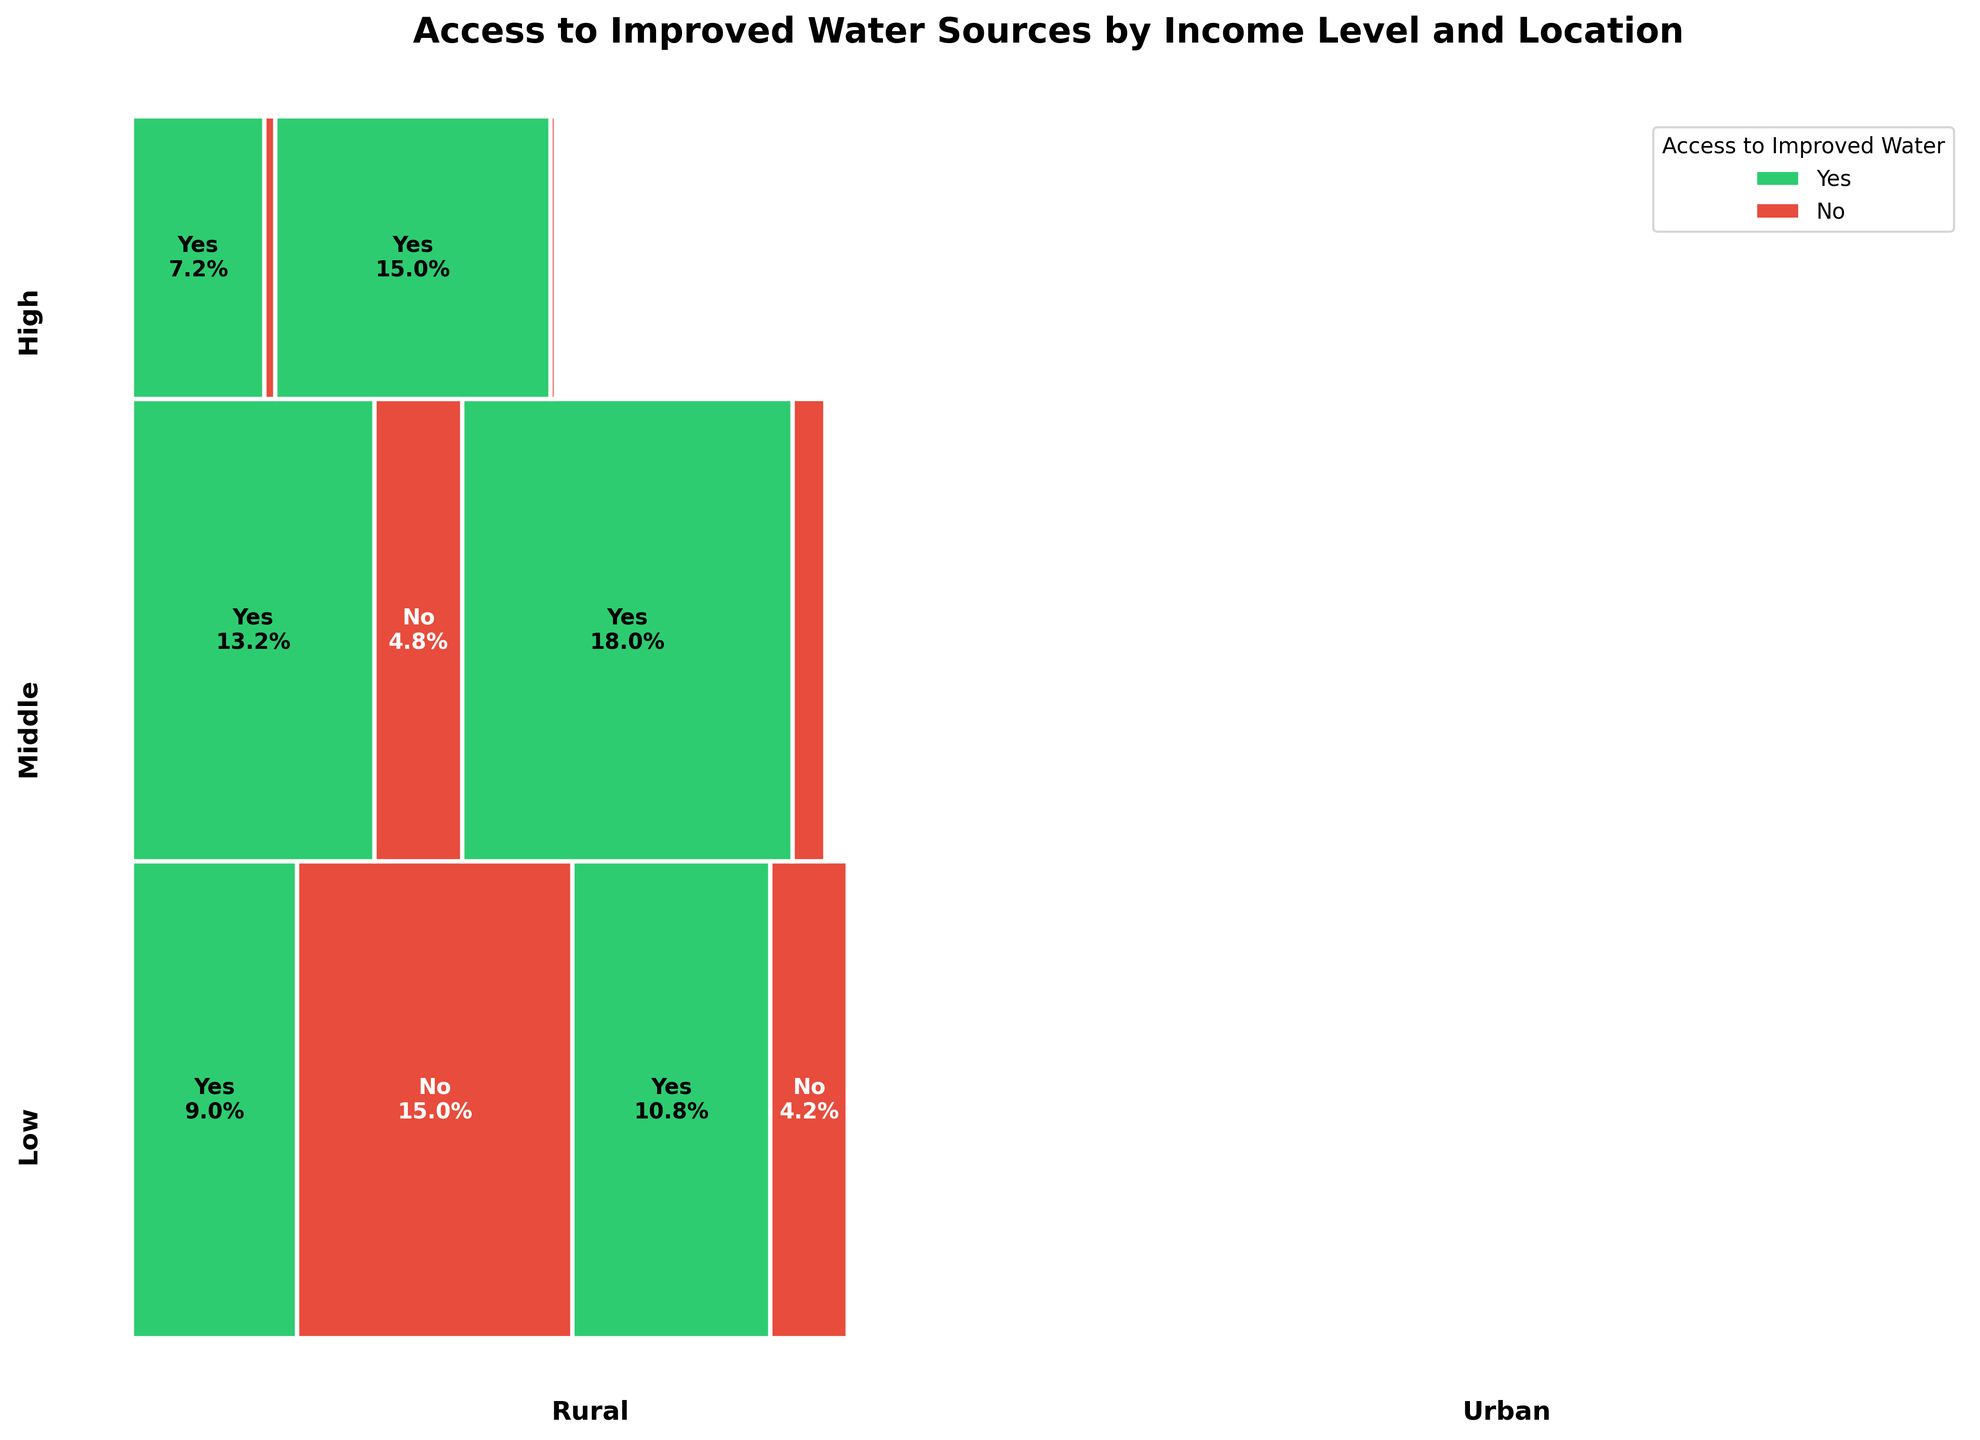What percentage of the urban population in low-income countries has access to improved water sources? In the mosaic plot, look at the segment labeled "Urban" under "Low" income level. The figure shows this segment explicitly marked with percentages for access to improved water sources.
Answer: 72% What is the total proportion of the population without access to improved water sources across all regions and income levels? Sum up the width of all red segments in the plot. Red segments represent the proportion of the population without access to improved water sources.
Answer: Approximately 30.6% Which geographical location has a higher percentage of people with access to improved water sources at the high-income level, rural or urban? Compare the widths of green segments (representing access) for rural and urban within the high-income level section.
Answer: Urban How does the proportion of the rural population with no access to improved water sources compare between low and middle-income levels? Look at the red segments for "Rural" under both low and middle-income levels. Compare their widths.
Answer: The proportion is higher in low-income levels Which income level has the smallest percentage of people without access to improved water sources in urban areas? Look at the red segments for "Urban" under each income level and identify the smallest one.
Answer: High What percentage of the rural population at middle-income level has access to improved water sources? Look at the rural segment under the middle-income section and identify the green segment's percentage.
Answer: 73.3% Compare the overall access to improved water sources between urban areas in low-income countries and rural areas in high-income countries. Which has better access? Compare the widths of the green segments under "Urban" in low-income and "Rural" in high-income sections. Urban areas in low-income countries appear to have better access.
Answer: Urban areas in low-income countries How does the distribution of access to improved water sources in urban areas vary across different income levels? Analyze the green and red segments for "Urban" in low, middle, and high-income sections.
Answer: Proportionally increases with income level Which population segment (based on geographical location and income) has the lowest access to improved water sources? Identify the smallest green segment across all combinations of income levels and locations.
Answer: Rural, Low-income 